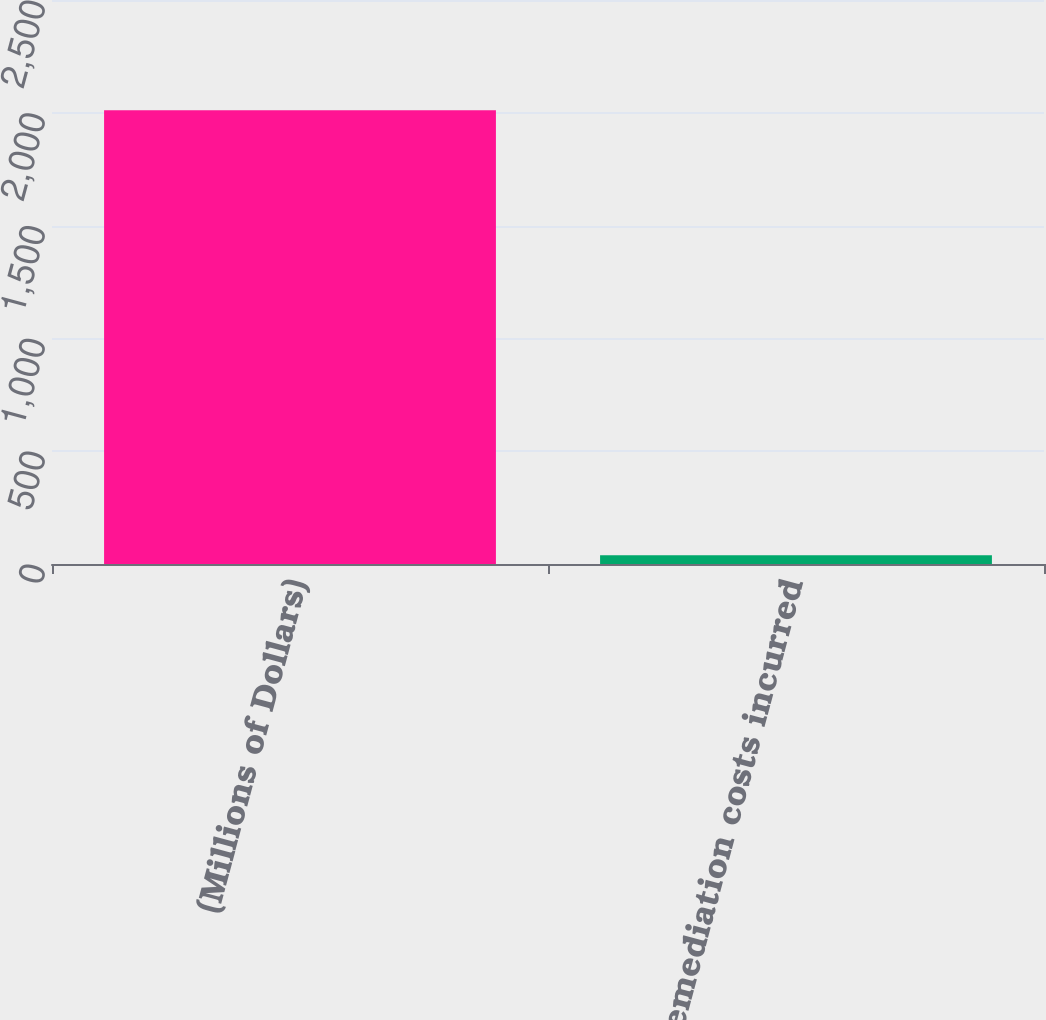Convert chart. <chart><loc_0><loc_0><loc_500><loc_500><bar_chart><fcel>(Millions of Dollars)<fcel>Remediation costs incurred<nl><fcel>2011<fcel>39<nl></chart> 